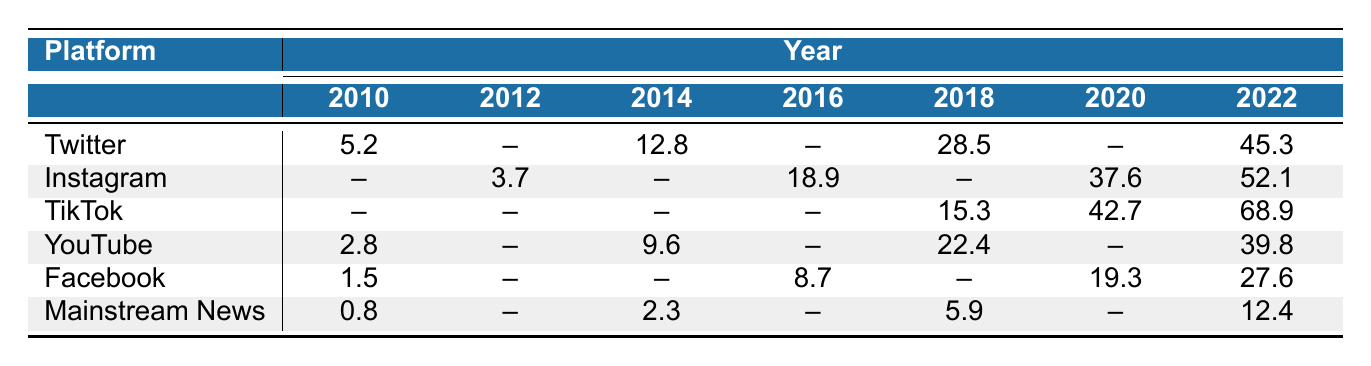What was the slang adoption rate on Twitter in 2022? The table shows that the adoption rate for Twitter in 2022 is 45.3%.
Answer: 45.3% Which platform had the highest adoption rate of African American slang in 2022? In 2022, TikTok had the highest adoption rate at 68.9%, compared to other platforms listed.
Answer: TikTok What was the adoption rate on Facebook in 2010? According to the table, Facebook's adoption rate in 2010 was 1.5%.
Answer: 1.5% Calculate the average slang adoption rate on Instagram across the years available in the table. The available years for Instagram are 2012 (3.7), 2016 (18.9), 2020 (37.6), and 2022 (52.1). Summing these values gives 3.7 + 18.9 + 37.6 + 52.1 = 112.3. There are 4 years, so the average is 112.3 / 4 = 28.075.
Answer: 28.075 Did the adoption rate of African American slang in mainstream news increase from 2010 to 2022? Yes, the table indicates an increase in the adoption rate in mainstream news from 0.8% in 2010 to 12.4% in 2022.
Answer: Yes Which platform saw the largest percentage increase in slang adoption from 2018 to 2022? TikTok's adoption rate increased from 42.7% in 2020 to 68.9% in 2022, which is an increase of 26.2 percentage points. Instagram also increased significantly but less so in comparison. Thus, TikTok saw the largest percentage increase from 2020 to 2022.
Answer: TikTok What was the slang adoption rate on YouTube in 2014? The table shows that the adoption rate on YouTube in 2014 was 9.6%.
Answer: 9.6% Is there a year where Instagram recorded a lower adoption rate than any other platform in the table? Yes, Instagram's adoption rate in 2012 (3.7%) was lower than Facebook's in the same year as well as other platforms in different years, particularly in 2010, where Twitter was 5.2%.
Answer: Yes Calculate the combined slang adoption rate for Twitter and YouTube in 2018. The adoption rates for Twitter and YouTube in 2018 are 28.5% and 22.4%, respectively. Adding these gives 28.5 + 22.4 = 50.9%.
Answer: 50.9% What is the trend of slang adoption rates in TikTok from 2018 to 2022? TikTok showed a clear upward trend: 15.3% in 2018, 42.7% in 2020, and then 68.9% in 2022, indicating significant growth.
Answer: Upward trend 